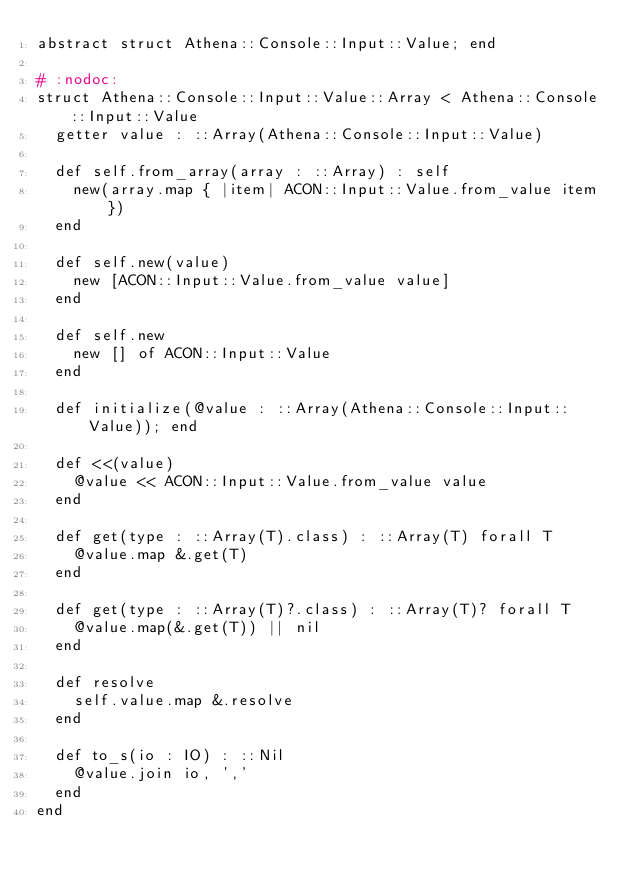Convert code to text. <code><loc_0><loc_0><loc_500><loc_500><_Crystal_>abstract struct Athena::Console::Input::Value; end

# :nodoc:
struct Athena::Console::Input::Value::Array < Athena::Console::Input::Value
  getter value : ::Array(Athena::Console::Input::Value)

  def self.from_array(array : ::Array) : self
    new(array.map { |item| ACON::Input::Value.from_value item })
  end

  def self.new(value)
    new [ACON::Input::Value.from_value value]
  end

  def self.new
    new [] of ACON::Input::Value
  end

  def initialize(@value : ::Array(Athena::Console::Input::Value)); end

  def <<(value)
    @value << ACON::Input::Value.from_value value
  end

  def get(type : ::Array(T).class) : ::Array(T) forall T
    @value.map &.get(T)
  end

  def get(type : ::Array(T)?.class) : ::Array(T)? forall T
    @value.map(&.get(T)) || nil
  end

  def resolve
    self.value.map &.resolve
  end

  def to_s(io : IO) : ::Nil
    @value.join io, ','
  end
end
</code> 